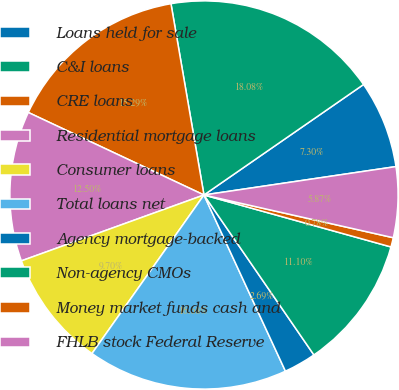Convert chart. <chart><loc_0><loc_0><loc_500><loc_500><pie_chart><fcel>Loans held for sale<fcel>C&I loans<fcel>CRE loans<fcel>Residential mortgage loans<fcel>Consumer loans<fcel>Total loans net<fcel>Agency mortgage-backed<fcel>Non-agency CMOs<fcel>Money market funds cash and<fcel>FHLB stock Federal Reserve<nl><fcel>7.3%<fcel>18.08%<fcel>15.29%<fcel>12.5%<fcel>9.7%<fcel>16.68%<fcel>2.69%<fcel>11.1%<fcel>0.78%<fcel>5.87%<nl></chart> 